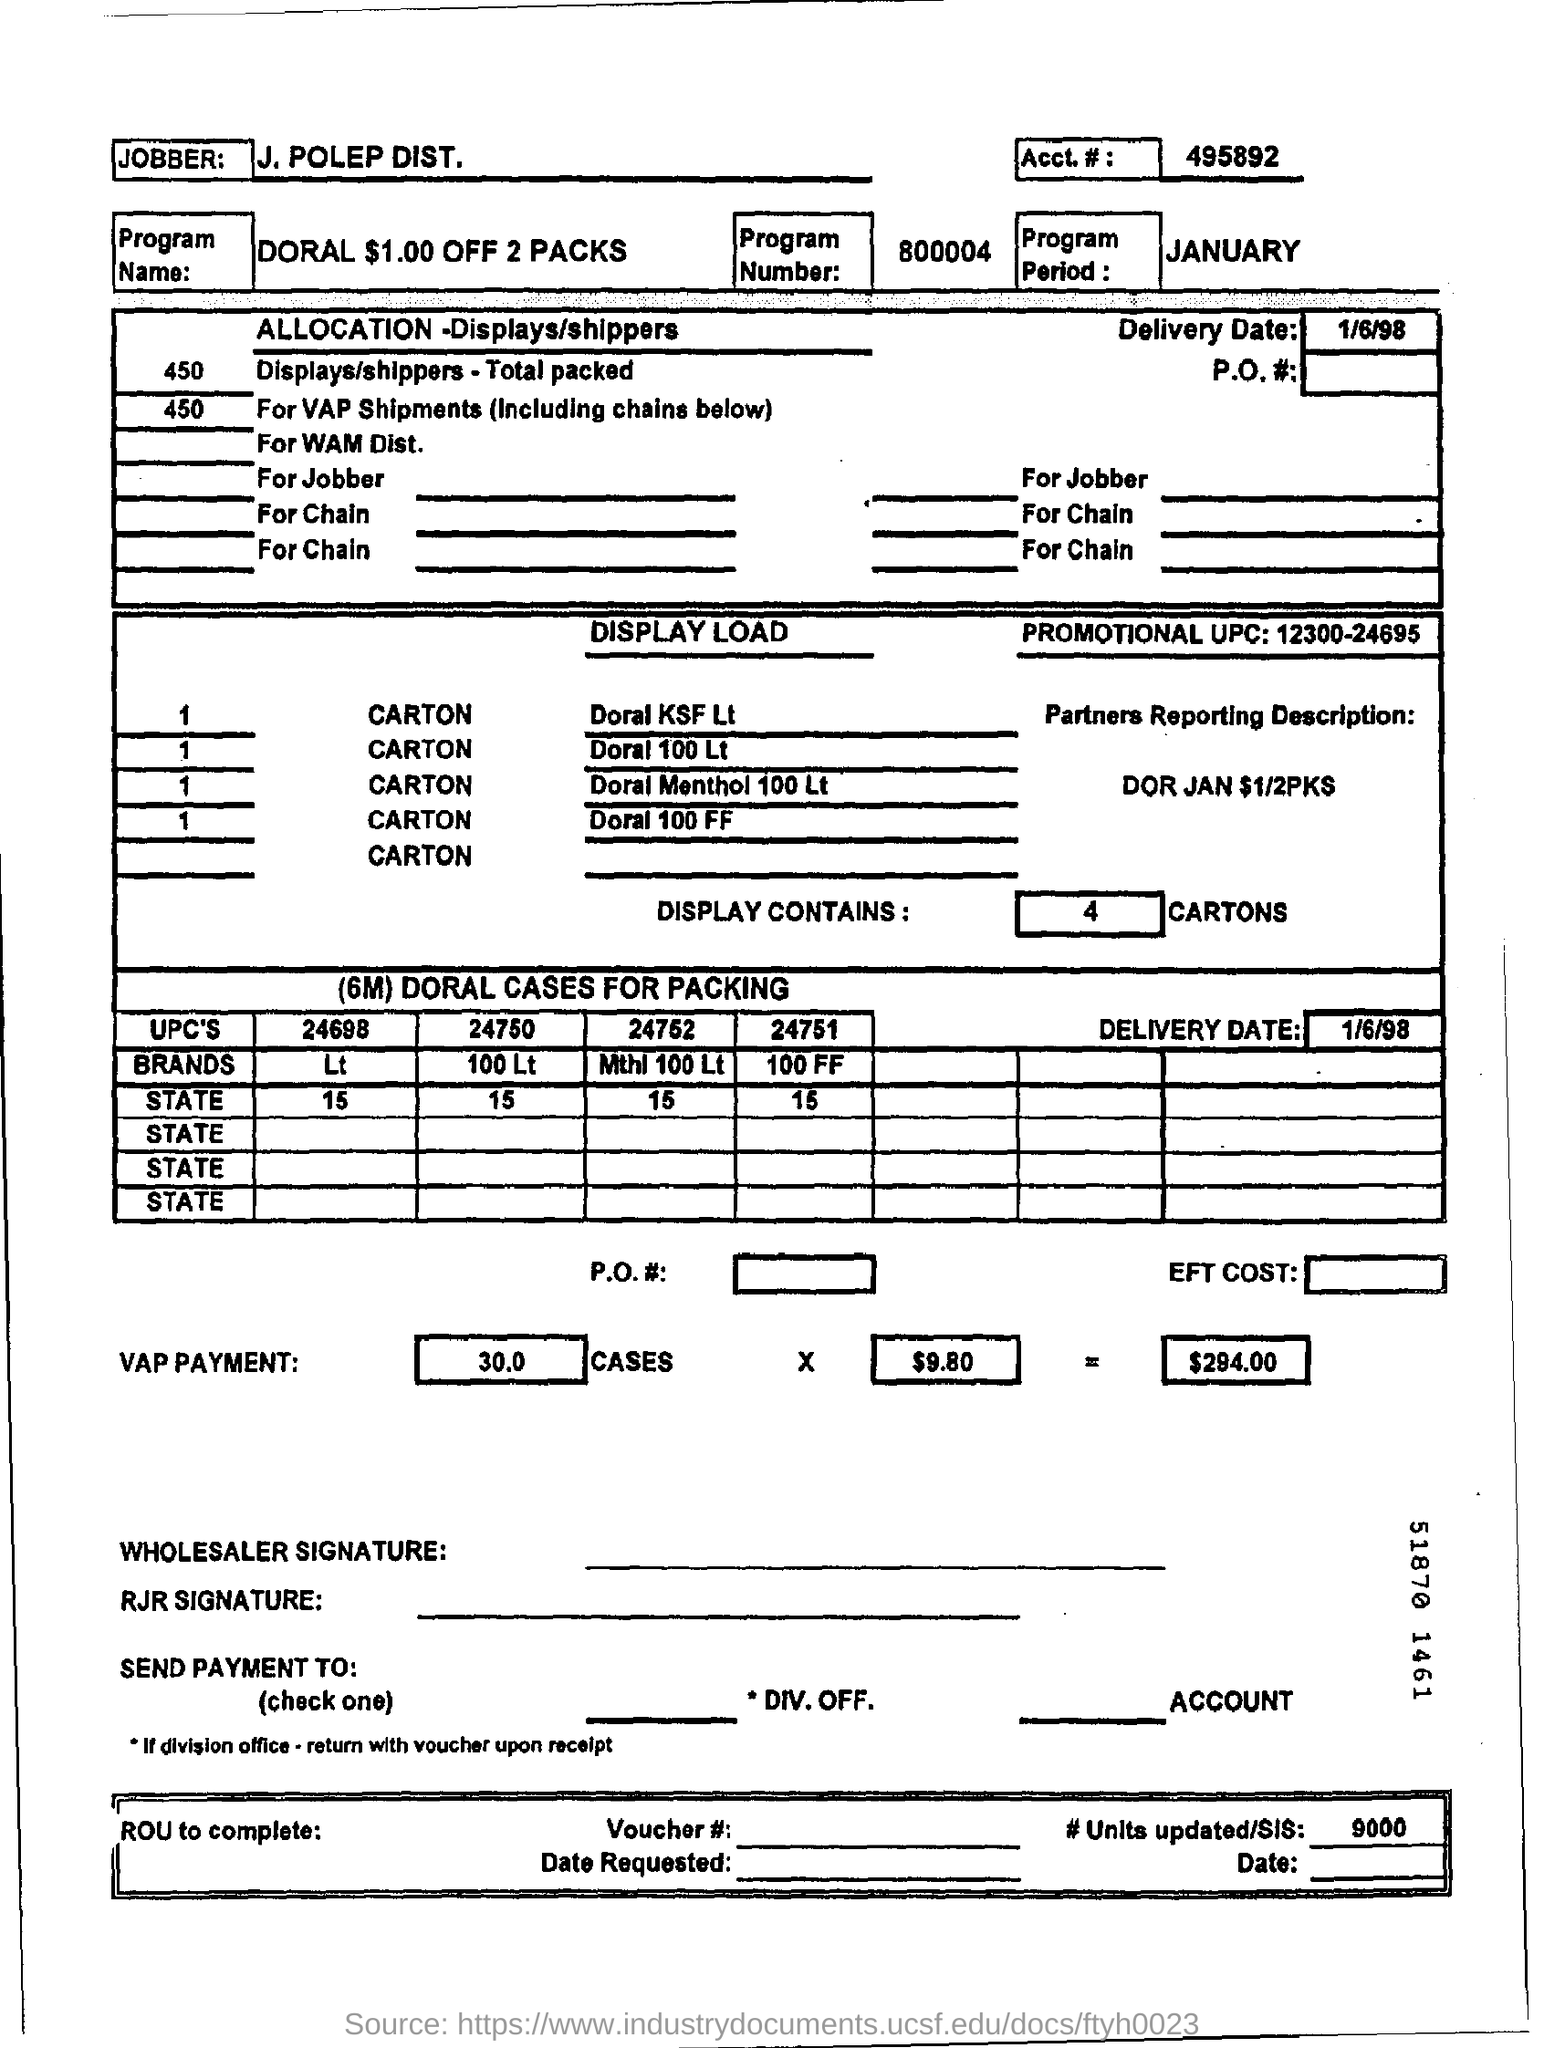Who is the jobber?
Provide a succinct answer. J. POLEP DIST. What is the Account # ?
Your answer should be compact. 495892. What is the program name?
Make the answer very short. DORAL $1.00 OFF 2 PACKS. What is the program number?
Your answer should be compact. 800004. When is the program period?
Your answer should be compact. JANUARY. What is the total VAP PAYMENT?
Provide a succinct answer. $294.00. When is the delivery date?
Your answer should be very brief. 1/6/98. 